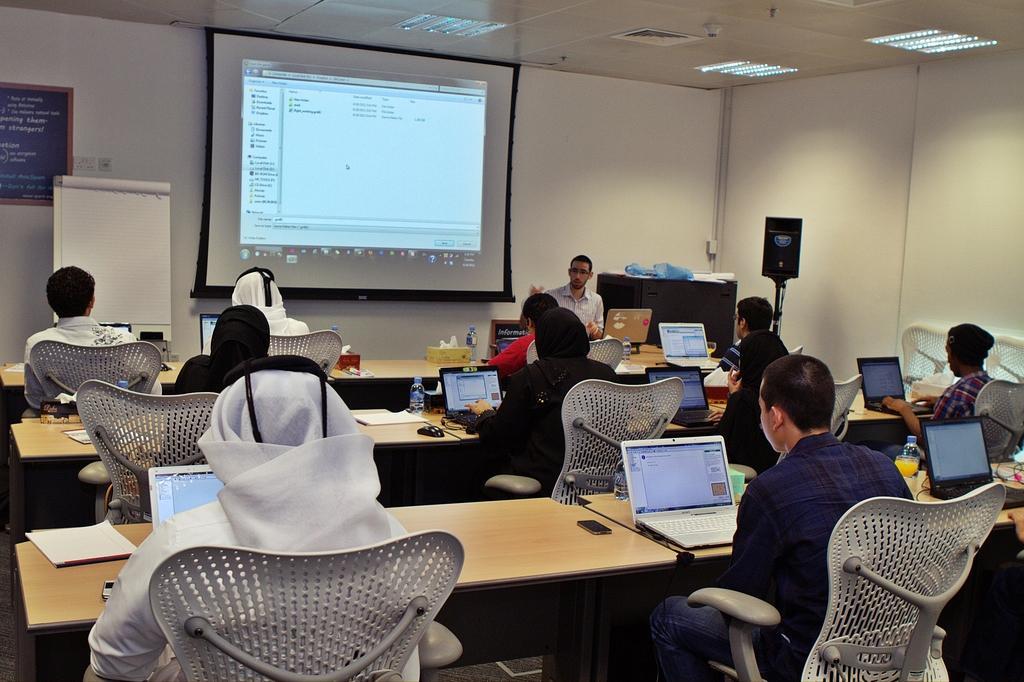Describe this image in one or two sentences. This picture is clicked in a classroom. The classroom is filled with tables, chairs and people. To the left side there is a person wearing grey sweater. To the right there is another person wearing a blue check shirt and staring at the laptop. All the persons are working on the laptop. In the top there is a projector screen. In the top there is a ceiling. 